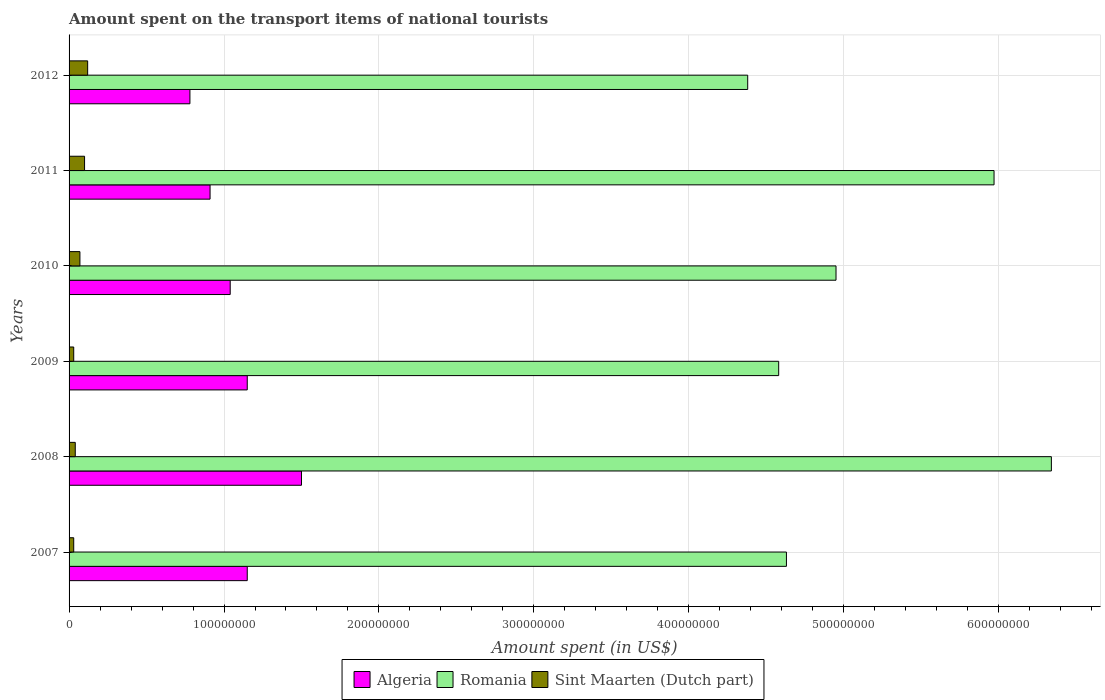How many different coloured bars are there?
Keep it short and to the point. 3. Are the number of bars per tick equal to the number of legend labels?
Offer a terse response. Yes. What is the label of the 2nd group of bars from the top?
Your answer should be compact. 2011. In how many cases, is the number of bars for a given year not equal to the number of legend labels?
Your answer should be very brief. 0. What is the amount spent on the transport items of national tourists in Sint Maarten (Dutch part) in 2012?
Make the answer very short. 1.20e+07. Across all years, what is the maximum amount spent on the transport items of national tourists in Algeria?
Make the answer very short. 1.50e+08. Across all years, what is the minimum amount spent on the transport items of national tourists in Romania?
Keep it short and to the point. 4.38e+08. In which year was the amount spent on the transport items of national tourists in Sint Maarten (Dutch part) maximum?
Keep it short and to the point. 2012. What is the total amount spent on the transport items of national tourists in Algeria in the graph?
Keep it short and to the point. 6.53e+08. What is the difference between the amount spent on the transport items of national tourists in Algeria in 2007 and that in 2010?
Give a very brief answer. 1.10e+07. What is the difference between the amount spent on the transport items of national tourists in Sint Maarten (Dutch part) in 2009 and the amount spent on the transport items of national tourists in Romania in 2008?
Keep it short and to the point. -6.31e+08. What is the average amount spent on the transport items of national tourists in Romania per year?
Your answer should be very brief. 5.14e+08. In the year 2011, what is the difference between the amount spent on the transport items of national tourists in Sint Maarten (Dutch part) and amount spent on the transport items of national tourists in Romania?
Make the answer very short. -5.87e+08. In how many years, is the amount spent on the transport items of national tourists in Algeria greater than 180000000 US$?
Your response must be concise. 0. What is the ratio of the amount spent on the transport items of national tourists in Algeria in 2007 to that in 2012?
Offer a very short reply. 1.47. Is the amount spent on the transport items of national tourists in Sint Maarten (Dutch part) in 2007 less than that in 2011?
Give a very brief answer. Yes. Is the difference between the amount spent on the transport items of national tourists in Sint Maarten (Dutch part) in 2011 and 2012 greater than the difference between the amount spent on the transport items of national tourists in Romania in 2011 and 2012?
Provide a succinct answer. No. What is the difference between the highest and the second highest amount spent on the transport items of national tourists in Algeria?
Your response must be concise. 3.50e+07. What is the difference between the highest and the lowest amount spent on the transport items of national tourists in Sint Maarten (Dutch part)?
Offer a terse response. 9.00e+06. Is the sum of the amount spent on the transport items of national tourists in Algeria in 2011 and 2012 greater than the maximum amount spent on the transport items of national tourists in Romania across all years?
Offer a very short reply. No. What does the 1st bar from the top in 2007 represents?
Provide a short and direct response. Sint Maarten (Dutch part). What does the 2nd bar from the bottom in 2012 represents?
Your answer should be very brief. Romania. Is it the case that in every year, the sum of the amount spent on the transport items of national tourists in Algeria and amount spent on the transport items of national tourists in Romania is greater than the amount spent on the transport items of national tourists in Sint Maarten (Dutch part)?
Provide a short and direct response. Yes. How many years are there in the graph?
Keep it short and to the point. 6. What is the difference between two consecutive major ticks on the X-axis?
Give a very brief answer. 1.00e+08. Does the graph contain grids?
Keep it short and to the point. Yes. How many legend labels are there?
Offer a terse response. 3. How are the legend labels stacked?
Your response must be concise. Horizontal. What is the title of the graph?
Offer a very short reply. Amount spent on the transport items of national tourists. Does "Euro area" appear as one of the legend labels in the graph?
Provide a short and direct response. No. What is the label or title of the X-axis?
Offer a very short reply. Amount spent (in US$). What is the label or title of the Y-axis?
Offer a very short reply. Years. What is the Amount spent (in US$) in Algeria in 2007?
Keep it short and to the point. 1.15e+08. What is the Amount spent (in US$) of Romania in 2007?
Offer a terse response. 4.63e+08. What is the Amount spent (in US$) in Sint Maarten (Dutch part) in 2007?
Ensure brevity in your answer.  3.00e+06. What is the Amount spent (in US$) of Algeria in 2008?
Keep it short and to the point. 1.50e+08. What is the Amount spent (in US$) of Romania in 2008?
Your response must be concise. 6.34e+08. What is the Amount spent (in US$) in Algeria in 2009?
Your answer should be very brief. 1.15e+08. What is the Amount spent (in US$) of Romania in 2009?
Offer a terse response. 4.58e+08. What is the Amount spent (in US$) of Sint Maarten (Dutch part) in 2009?
Offer a terse response. 3.00e+06. What is the Amount spent (in US$) in Algeria in 2010?
Your answer should be very brief. 1.04e+08. What is the Amount spent (in US$) of Romania in 2010?
Ensure brevity in your answer.  4.95e+08. What is the Amount spent (in US$) in Algeria in 2011?
Ensure brevity in your answer.  9.10e+07. What is the Amount spent (in US$) of Romania in 2011?
Your answer should be compact. 5.97e+08. What is the Amount spent (in US$) in Algeria in 2012?
Your answer should be very brief. 7.80e+07. What is the Amount spent (in US$) of Romania in 2012?
Make the answer very short. 4.38e+08. What is the Amount spent (in US$) in Sint Maarten (Dutch part) in 2012?
Provide a short and direct response. 1.20e+07. Across all years, what is the maximum Amount spent (in US$) in Algeria?
Provide a succinct answer. 1.50e+08. Across all years, what is the maximum Amount spent (in US$) in Romania?
Give a very brief answer. 6.34e+08. Across all years, what is the maximum Amount spent (in US$) in Sint Maarten (Dutch part)?
Your response must be concise. 1.20e+07. Across all years, what is the minimum Amount spent (in US$) in Algeria?
Your answer should be compact. 7.80e+07. Across all years, what is the minimum Amount spent (in US$) of Romania?
Offer a terse response. 4.38e+08. Across all years, what is the minimum Amount spent (in US$) of Sint Maarten (Dutch part)?
Your response must be concise. 3.00e+06. What is the total Amount spent (in US$) in Algeria in the graph?
Offer a very short reply. 6.53e+08. What is the total Amount spent (in US$) of Romania in the graph?
Offer a terse response. 3.08e+09. What is the total Amount spent (in US$) in Sint Maarten (Dutch part) in the graph?
Provide a short and direct response. 3.90e+07. What is the difference between the Amount spent (in US$) in Algeria in 2007 and that in 2008?
Offer a very short reply. -3.50e+07. What is the difference between the Amount spent (in US$) of Romania in 2007 and that in 2008?
Offer a very short reply. -1.71e+08. What is the difference between the Amount spent (in US$) of Algeria in 2007 and that in 2009?
Offer a terse response. 0. What is the difference between the Amount spent (in US$) of Algeria in 2007 and that in 2010?
Your answer should be very brief. 1.10e+07. What is the difference between the Amount spent (in US$) of Romania in 2007 and that in 2010?
Your answer should be compact. -3.20e+07. What is the difference between the Amount spent (in US$) of Sint Maarten (Dutch part) in 2007 and that in 2010?
Your response must be concise. -4.00e+06. What is the difference between the Amount spent (in US$) of Algeria in 2007 and that in 2011?
Keep it short and to the point. 2.40e+07. What is the difference between the Amount spent (in US$) of Romania in 2007 and that in 2011?
Give a very brief answer. -1.34e+08. What is the difference between the Amount spent (in US$) in Sint Maarten (Dutch part) in 2007 and that in 2011?
Provide a succinct answer. -7.00e+06. What is the difference between the Amount spent (in US$) in Algeria in 2007 and that in 2012?
Ensure brevity in your answer.  3.70e+07. What is the difference between the Amount spent (in US$) in Romania in 2007 and that in 2012?
Your answer should be compact. 2.50e+07. What is the difference between the Amount spent (in US$) of Sint Maarten (Dutch part) in 2007 and that in 2012?
Give a very brief answer. -9.00e+06. What is the difference between the Amount spent (in US$) in Algeria in 2008 and that in 2009?
Offer a very short reply. 3.50e+07. What is the difference between the Amount spent (in US$) of Romania in 2008 and that in 2009?
Your response must be concise. 1.76e+08. What is the difference between the Amount spent (in US$) in Sint Maarten (Dutch part) in 2008 and that in 2009?
Make the answer very short. 1.00e+06. What is the difference between the Amount spent (in US$) of Algeria in 2008 and that in 2010?
Keep it short and to the point. 4.60e+07. What is the difference between the Amount spent (in US$) of Romania in 2008 and that in 2010?
Ensure brevity in your answer.  1.39e+08. What is the difference between the Amount spent (in US$) in Algeria in 2008 and that in 2011?
Give a very brief answer. 5.90e+07. What is the difference between the Amount spent (in US$) in Romania in 2008 and that in 2011?
Your answer should be compact. 3.70e+07. What is the difference between the Amount spent (in US$) in Sint Maarten (Dutch part) in 2008 and that in 2011?
Make the answer very short. -6.00e+06. What is the difference between the Amount spent (in US$) in Algeria in 2008 and that in 2012?
Provide a short and direct response. 7.20e+07. What is the difference between the Amount spent (in US$) in Romania in 2008 and that in 2012?
Keep it short and to the point. 1.96e+08. What is the difference between the Amount spent (in US$) of Sint Maarten (Dutch part) in 2008 and that in 2012?
Your answer should be compact. -8.00e+06. What is the difference between the Amount spent (in US$) in Algeria in 2009 and that in 2010?
Keep it short and to the point. 1.10e+07. What is the difference between the Amount spent (in US$) in Romania in 2009 and that in 2010?
Offer a very short reply. -3.70e+07. What is the difference between the Amount spent (in US$) in Algeria in 2009 and that in 2011?
Provide a short and direct response. 2.40e+07. What is the difference between the Amount spent (in US$) of Romania in 2009 and that in 2011?
Provide a succinct answer. -1.39e+08. What is the difference between the Amount spent (in US$) of Sint Maarten (Dutch part) in 2009 and that in 2011?
Ensure brevity in your answer.  -7.00e+06. What is the difference between the Amount spent (in US$) in Algeria in 2009 and that in 2012?
Give a very brief answer. 3.70e+07. What is the difference between the Amount spent (in US$) in Sint Maarten (Dutch part) in 2009 and that in 2012?
Give a very brief answer. -9.00e+06. What is the difference between the Amount spent (in US$) in Algeria in 2010 and that in 2011?
Make the answer very short. 1.30e+07. What is the difference between the Amount spent (in US$) of Romania in 2010 and that in 2011?
Provide a short and direct response. -1.02e+08. What is the difference between the Amount spent (in US$) of Algeria in 2010 and that in 2012?
Keep it short and to the point. 2.60e+07. What is the difference between the Amount spent (in US$) in Romania in 2010 and that in 2012?
Your answer should be very brief. 5.70e+07. What is the difference between the Amount spent (in US$) of Sint Maarten (Dutch part) in 2010 and that in 2012?
Provide a short and direct response. -5.00e+06. What is the difference between the Amount spent (in US$) of Algeria in 2011 and that in 2012?
Ensure brevity in your answer.  1.30e+07. What is the difference between the Amount spent (in US$) in Romania in 2011 and that in 2012?
Make the answer very short. 1.59e+08. What is the difference between the Amount spent (in US$) in Sint Maarten (Dutch part) in 2011 and that in 2012?
Your response must be concise. -2.00e+06. What is the difference between the Amount spent (in US$) of Algeria in 2007 and the Amount spent (in US$) of Romania in 2008?
Offer a very short reply. -5.19e+08. What is the difference between the Amount spent (in US$) in Algeria in 2007 and the Amount spent (in US$) in Sint Maarten (Dutch part) in 2008?
Ensure brevity in your answer.  1.11e+08. What is the difference between the Amount spent (in US$) in Romania in 2007 and the Amount spent (in US$) in Sint Maarten (Dutch part) in 2008?
Provide a short and direct response. 4.59e+08. What is the difference between the Amount spent (in US$) of Algeria in 2007 and the Amount spent (in US$) of Romania in 2009?
Offer a terse response. -3.43e+08. What is the difference between the Amount spent (in US$) in Algeria in 2007 and the Amount spent (in US$) in Sint Maarten (Dutch part) in 2009?
Offer a terse response. 1.12e+08. What is the difference between the Amount spent (in US$) of Romania in 2007 and the Amount spent (in US$) of Sint Maarten (Dutch part) in 2009?
Your response must be concise. 4.60e+08. What is the difference between the Amount spent (in US$) in Algeria in 2007 and the Amount spent (in US$) in Romania in 2010?
Your answer should be very brief. -3.80e+08. What is the difference between the Amount spent (in US$) of Algeria in 2007 and the Amount spent (in US$) of Sint Maarten (Dutch part) in 2010?
Make the answer very short. 1.08e+08. What is the difference between the Amount spent (in US$) in Romania in 2007 and the Amount spent (in US$) in Sint Maarten (Dutch part) in 2010?
Provide a short and direct response. 4.56e+08. What is the difference between the Amount spent (in US$) of Algeria in 2007 and the Amount spent (in US$) of Romania in 2011?
Give a very brief answer. -4.82e+08. What is the difference between the Amount spent (in US$) in Algeria in 2007 and the Amount spent (in US$) in Sint Maarten (Dutch part) in 2011?
Provide a short and direct response. 1.05e+08. What is the difference between the Amount spent (in US$) in Romania in 2007 and the Amount spent (in US$) in Sint Maarten (Dutch part) in 2011?
Provide a short and direct response. 4.53e+08. What is the difference between the Amount spent (in US$) of Algeria in 2007 and the Amount spent (in US$) of Romania in 2012?
Keep it short and to the point. -3.23e+08. What is the difference between the Amount spent (in US$) in Algeria in 2007 and the Amount spent (in US$) in Sint Maarten (Dutch part) in 2012?
Offer a very short reply. 1.03e+08. What is the difference between the Amount spent (in US$) of Romania in 2007 and the Amount spent (in US$) of Sint Maarten (Dutch part) in 2012?
Provide a succinct answer. 4.51e+08. What is the difference between the Amount spent (in US$) of Algeria in 2008 and the Amount spent (in US$) of Romania in 2009?
Your answer should be very brief. -3.08e+08. What is the difference between the Amount spent (in US$) in Algeria in 2008 and the Amount spent (in US$) in Sint Maarten (Dutch part) in 2009?
Your answer should be compact. 1.47e+08. What is the difference between the Amount spent (in US$) of Romania in 2008 and the Amount spent (in US$) of Sint Maarten (Dutch part) in 2009?
Your response must be concise. 6.31e+08. What is the difference between the Amount spent (in US$) in Algeria in 2008 and the Amount spent (in US$) in Romania in 2010?
Ensure brevity in your answer.  -3.45e+08. What is the difference between the Amount spent (in US$) of Algeria in 2008 and the Amount spent (in US$) of Sint Maarten (Dutch part) in 2010?
Provide a short and direct response. 1.43e+08. What is the difference between the Amount spent (in US$) in Romania in 2008 and the Amount spent (in US$) in Sint Maarten (Dutch part) in 2010?
Ensure brevity in your answer.  6.27e+08. What is the difference between the Amount spent (in US$) in Algeria in 2008 and the Amount spent (in US$) in Romania in 2011?
Your answer should be very brief. -4.47e+08. What is the difference between the Amount spent (in US$) in Algeria in 2008 and the Amount spent (in US$) in Sint Maarten (Dutch part) in 2011?
Keep it short and to the point. 1.40e+08. What is the difference between the Amount spent (in US$) of Romania in 2008 and the Amount spent (in US$) of Sint Maarten (Dutch part) in 2011?
Keep it short and to the point. 6.24e+08. What is the difference between the Amount spent (in US$) in Algeria in 2008 and the Amount spent (in US$) in Romania in 2012?
Make the answer very short. -2.88e+08. What is the difference between the Amount spent (in US$) in Algeria in 2008 and the Amount spent (in US$) in Sint Maarten (Dutch part) in 2012?
Keep it short and to the point. 1.38e+08. What is the difference between the Amount spent (in US$) of Romania in 2008 and the Amount spent (in US$) of Sint Maarten (Dutch part) in 2012?
Keep it short and to the point. 6.22e+08. What is the difference between the Amount spent (in US$) in Algeria in 2009 and the Amount spent (in US$) in Romania in 2010?
Keep it short and to the point. -3.80e+08. What is the difference between the Amount spent (in US$) of Algeria in 2009 and the Amount spent (in US$) of Sint Maarten (Dutch part) in 2010?
Give a very brief answer. 1.08e+08. What is the difference between the Amount spent (in US$) in Romania in 2009 and the Amount spent (in US$) in Sint Maarten (Dutch part) in 2010?
Provide a short and direct response. 4.51e+08. What is the difference between the Amount spent (in US$) of Algeria in 2009 and the Amount spent (in US$) of Romania in 2011?
Offer a terse response. -4.82e+08. What is the difference between the Amount spent (in US$) of Algeria in 2009 and the Amount spent (in US$) of Sint Maarten (Dutch part) in 2011?
Your response must be concise. 1.05e+08. What is the difference between the Amount spent (in US$) in Romania in 2009 and the Amount spent (in US$) in Sint Maarten (Dutch part) in 2011?
Keep it short and to the point. 4.48e+08. What is the difference between the Amount spent (in US$) of Algeria in 2009 and the Amount spent (in US$) of Romania in 2012?
Give a very brief answer. -3.23e+08. What is the difference between the Amount spent (in US$) in Algeria in 2009 and the Amount spent (in US$) in Sint Maarten (Dutch part) in 2012?
Provide a succinct answer. 1.03e+08. What is the difference between the Amount spent (in US$) in Romania in 2009 and the Amount spent (in US$) in Sint Maarten (Dutch part) in 2012?
Your response must be concise. 4.46e+08. What is the difference between the Amount spent (in US$) of Algeria in 2010 and the Amount spent (in US$) of Romania in 2011?
Offer a terse response. -4.93e+08. What is the difference between the Amount spent (in US$) in Algeria in 2010 and the Amount spent (in US$) in Sint Maarten (Dutch part) in 2011?
Give a very brief answer. 9.40e+07. What is the difference between the Amount spent (in US$) of Romania in 2010 and the Amount spent (in US$) of Sint Maarten (Dutch part) in 2011?
Provide a succinct answer. 4.85e+08. What is the difference between the Amount spent (in US$) of Algeria in 2010 and the Amount spent (in US$) of Romania in 2012?
Provide a short and direct response. -3.34e+08. What is the difference between the Amount spent (in US$) in Algeria in 2010 and the Amount spent (in US$) in Sint Maarten (Dutch part) in 2012?
Your response must be concise. 9.20e+07. What is the difference between the Amount spent (in US$) of Romania in 2010 and the Amount spent (in US$) of Sint Maarten (Dutch part) in 2012?
Your answer should be very brief. 4.83e+08. What is the difference between the Amount spent (in US$) of Algeria in 2011 and the Amount spent (in US$) of Romania in 2012?
Give a very brief answer. -3.47e+08. What is the difference between the Amount spent (in US$) of Algeria in 2011 and the Amount spent (in US$) of Sint Maarten (Dutch part) in 2012?
Your response must be concise. 7.90e+07. What is the difference between the Amount spent (in US$) in Romania in 2011 and the Amount spent (in US$) in Sint Maarten (Dutch part) in 2012?
Offer a terse response. 5.85e+08. What is the average Amount spent (in US$) in Algeria per year?
Your response must be concise. 1.09e+08. What is the average Amount spent (in US$) of Romania per year?
Keep it short and to the point. 5.14e+08. What is the average Amount spent (in US$) in Sint Maarten (Dutch part) per year?
Keep it short and to the point. 6.50e+06. In the year 2007, what is the difference between the Amount spent (in US$) in Algeria and Amount spent (in US$) in Romania?
Your answer should be compact. -3.48e+08. In the year 2007, what is the difference between the Amount spent (in US$) in Algeria and Amount spent (in US$) in Sint Maarten (Dutch part)?
Your response must be concise. 1.12e+08. In the year 2007, what is the difference between the Amount spent (in US$) of Romania and Amount spent (in US$) of Sint Maarten (Dutch part)?
Your answer should be very brief. 4.60e+08. In the year 2008, what is the difference between the Amount spent (in US$) in Algeria and Amount spent (in US$) in Romania?
Your answer should be very brief. -4.84e+08. In the year 2008, what is the difference between the Amount spent (in US$) of Algeria and Amount spent (in US$) of Sint Maarten (Dutch part)?
Offer a very short reply. 1.46e+08. In the year 2008, what is the difference between the Amount spent (in US$) in Romania and Amount spent (in US$) in Sint Maarten (Dutch part)?
Provide a succinct answer. 6.30e+08. In the year 2009, what is the difference between the Amount spent (in US$) of Algeria and Amount spent (in US$) of Romania?
Your answer should be very brief. -3.43e+08. In the year 2009, what is the difference between the Amount spent (in US$) in Algeria and Amount spent (in US$) in Sint Maarten (Dutch part)?
Ensure brevity in your answer.  1.12e+08. In the year 2009, what is the difference between the Amount spent (in US$) of Romania and Amount spent (in US$) of Sint Maarten (Dutch part)?
Ensure brevity in your answer.  4.55e+08. In the year 2010, what is the difference between the Amount spent (in US$) of Algeria and Amount spent (in US$) of Romania?
Your answer should be compact. -3.91e+08. In the year 2010, what is the difference between the Amount spent (in US$) of Algeria and Amount spent (in US$) of Sint Maarten (Dutch part)?
Provide a succinct answer. 9.70e+07. In the year 2010, what is the difference between the Amount spent (in US$) in Romania and Amount spent (in US$) in Sint Maarten (Dutch part)?
Your response must be concise. 4.88e+08. In the year 2011, what is the difference between the Amount spent (in US$) of Algeria and Amount spent (in US$) of Romania?
Provide a succinct answer. -5.06e+08. In the year 2011, what is the difference between the Amount spent (in US$) of Algeria and Amount spent (in US$) of Sint Maarten (Dutch part)?
Make the answer very short. 8.10e+07. In the year 2011, what is the difference between the Amount spent (in US$) in Romania and Amount spent (in US$) in Sint Maarten (Dutch part)?
Your answer should be very brief. 5.87e+08. In the year 2012, what is the difference between the Amount spent (in US$) of Algeria and Amount spent (in US$) of Romania?
Make the answer very short. -3.60e+08. In the year 2012, what is the difference between the Amount spent (in US$) of Algeria and Amount spent (in US$) of Sint Maarten (Dutch part)?
Your response must be concise. 6.60e+07. In the year 2012, what is the difference between the Amount spent (in US$) in Romania and Amount spent (in US$) in Sint Maarten (Dutch part)?
Keep it short and to the point. 4.26e+08. What is the ratio of the Amount spent (in US$) of Algeria in 2007 to that in 2008?
Offer a very short reply. 0.77. What is the ratio of the Amount spent (in US$) in Romania in 2007 to that in 2008?
Give a very brief answer. 0.73. What is the ratio of the Amount spent (in US$) of Romania in 2007 to that in 2009?
Offer a very short reply. 1.01. What is the ratio of the Amount spent (in US$) in Sint Maarten (Dutch part) in 2007 to that in 2009?
Make the answer very short. 1. What is the ratio of the Amount spent (in US$) of Algeria in 2007 to that in 2010?
Offer a very short reply. 1.11. What is the ratio of the Amount spent (in US$) of Romania in 2007 to that in 2010?
Keep it short and to the point. 0.94. What is the ratio of the Amount spent (in US$) in Sint Maarten (Dutch part) in 2007 to that in 2010?
Your answer should be very brief. 0.43. What is the ratio of the Amount spent (in US$) in Algeria in 2007 to that in 2011?
Your answer should be compact. 1.26. What is the ratio of the Amount spent (in US$) in Romania in 2007 to that in 2011?
Make the answer very short. 0.78. What is the ratio of the Amount spent (in US$) of Sint Maarten (Dutch part) in 2007 to that in 2011?
Make the answer very short. 0.3. What is the ratio of the Amount spent (in US$) of Algeria in 2007 to that in 2012?
Provide a short and direct response. 1.47. What is the ratio of the Amount spent (in US$) of Romania in 2007 to that in 2012?
Make the answer very short. 1.06. What is the ratio of the Amount spent (in US$) in Sint Maarten (Dutch part) in 2007 to that in 2012?
Your answer should be very brief. 0.25. What is the ratio of the Amount spent (in US$) in Algeria in 2008 to that in 2009?
Keep it short and to the point. 1.3. What is the ratio of the Amount spent (in US$) of Romania in 2008 to that in 2009?
Your response must be concise. 1.38. What is the ratio of the Amount spent (in US$) in Sint Maarten (Dutch part) in 2008 to that in 2009?
Give a very brief answer. 1.33. What is the ratio of the Amount spent (in US$) of Algeria in 2008 to that in 2010?
Ensure brevity in your answer.  1.44. What is the ratio of the Amount spent (in US$) of Romania in 2008 to that in 2010?
Give a very brief answer. 1.28. What is the ratio of the Amount spent (in US$) of Sint Maarten (Dutch part) in 2008 to that in 2010?
Keep it short and to the point. 0.57. What is the ratio of the Amount spent (in US$) in Algeria in 2008 to that in 2011?
Make the answer very short. 1.65. What is the ratio of the Amount spent (in US$) in Romania in 2008 to that in 2011?
Give a very brief answer. 1.06. What is the ratio of the Amount spent (in US$) of Sint Maarten (Dutch part) in 2008 to that in 2011?
Keep it short and to the point. 0.4. What is the ratio of the Amount spent (in US$) in Algeria in 2008 to that in 2012?
Offer a very short reply. 1.92. What is the ratio of the Amount spent (in US$) in Romania in 2008 to that in 2012?
Offer a very short reply. 1.45. What is the ratio of the Amount spent (in US$) in Algeria in 2009 to that in 2010?
Your answer should be compact. 1.11. What is the ratio of the Amount spent (in US$) of Romania in 2009 to that in 2010?
Ensure brevity in your answer.  0.93. What is the ratio of the Amount spent (in US$) in Sint Maarten (Dutch part) in 2009 to that in 2010?
Your answer should be compact. 0.43. What is the ratio of the Amount spent (in US$) of Algeria in 2009 to that in 2011?
Provide a succinct answer. 1.26. What is the ratio of the Amount spent (in US$) in Romania in 2009 to that in 2011?
Offer a very short reply. 0.77. What is the ratio of the Amount spent (in US$) of Sint Maarten (Dutch part) in 2009 to that in 2011?
Provide a succinct answer. 0.3. What is the ratio of the Amount spent (in US$) of Algeria in 2009 to that in 2012?
Give a very brief answer. 1.47. What is the ratio of the Amount spent (in US$) of Romania in 2009 to that in 2012?
Offer a very short reply. 1.05. What is the ratio of the Amount spent (in US$) in Romania in 2010 to that in 2011?
Your answer should be compact. 0.83. What is the ratio of the Amount spent (in US$) of Sint Maarten (Dutch part) in 2010 to that in 2011?
Make the answer very short. 0.7. What is the ratio of the Amount spent (in US$) of Algeria in 2010 to that in 2012?
Your response must be concise. 1.33. What is the ratio of the Amount spent (in US$) of Romania in 2010 to that in 2012?
Your answer should be compact. 1.13. What is the ratio of the Amount spent (in US$) of Sint Maarten (Dutch part) in 2010 to that in 2012?
Your response must be concise. 0.58. What is the ratio of the Amount spent (in US$) of Romania in 2011 to that in 2012?
Your answer should be compact. 1.36. What is the difference between the highest and the second highest Amount spent (in US$) of Algeria?
Keep it short and to the point. 3.50e+07. What is the difference between the highest and the second highest Amount spent (in US$) of Romania?
Your response must be concise. 3.70e+07. What is the difference between the highest and the second highest Amount spent (in US$) of Sint Maarten (Dutch part)?
Provide a succinct answer. 2.00e+06. What is the difference between the highest and the lowest Amount spent (in US$) of Algeria?
Your answer should be very brief. 7.20e+07. What is the difference between the highest and the lowest Amount spent (in US$) in Romania?
Give a very brief answer. 1.96e+08. What is the difference between the highest and the lowest Amount spent (in US$) of Sint Maarten (Dutch part)?
Provide a short and direct response. 9.00e+06. 